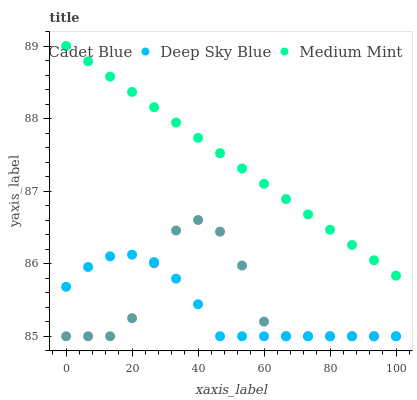Does Deep Sky Blue have the minimum area under the curve?
Answer yes or no. Yes. Does Medium Mint have the maximum area under the curve?
Answer yes or no. Yes. Does Cadet Blue have the minimum area under the curve?
Answer yes or no. No. Does Cadet Blue have the maximum area under the curve?
Answer yes or no. No. Is Medium Mint the smoothest?
Answer yes or no. Yes. Is Cadet Blue the roughest?
Answer yes or no. Yes. Is Deep Sky Blue the smoothest?
Answer yes or no. No. Is Deep Sky Blue the roughest?
Answer yes or no. No. Does Cadet Blue have the lowest value?
Answer yes or no. Yes. Does Medium Mint have the highest value?
Answer yes or no. Yes. Does Cadet Blue have the highest value?
Answer yes or no. No. Is Deep Sky Blue less than Medium Mint?
Answer yes or no. Yes. Is Medium Mint greater than Cadet Blue?
Answer yes or no. Yes. Does Deep Sky Blue intersect Cadet Blue?
Answer yes or no. Yes. Is Deep Sky Blue less than Cadet Blue?
Answer yes or no. No. Is Deep Sky Blue greater than Cadet Blue?
Answer yes or no. No. Does Deep Sky Blue intersect Medium Mint?
Answer yes or no. No. 